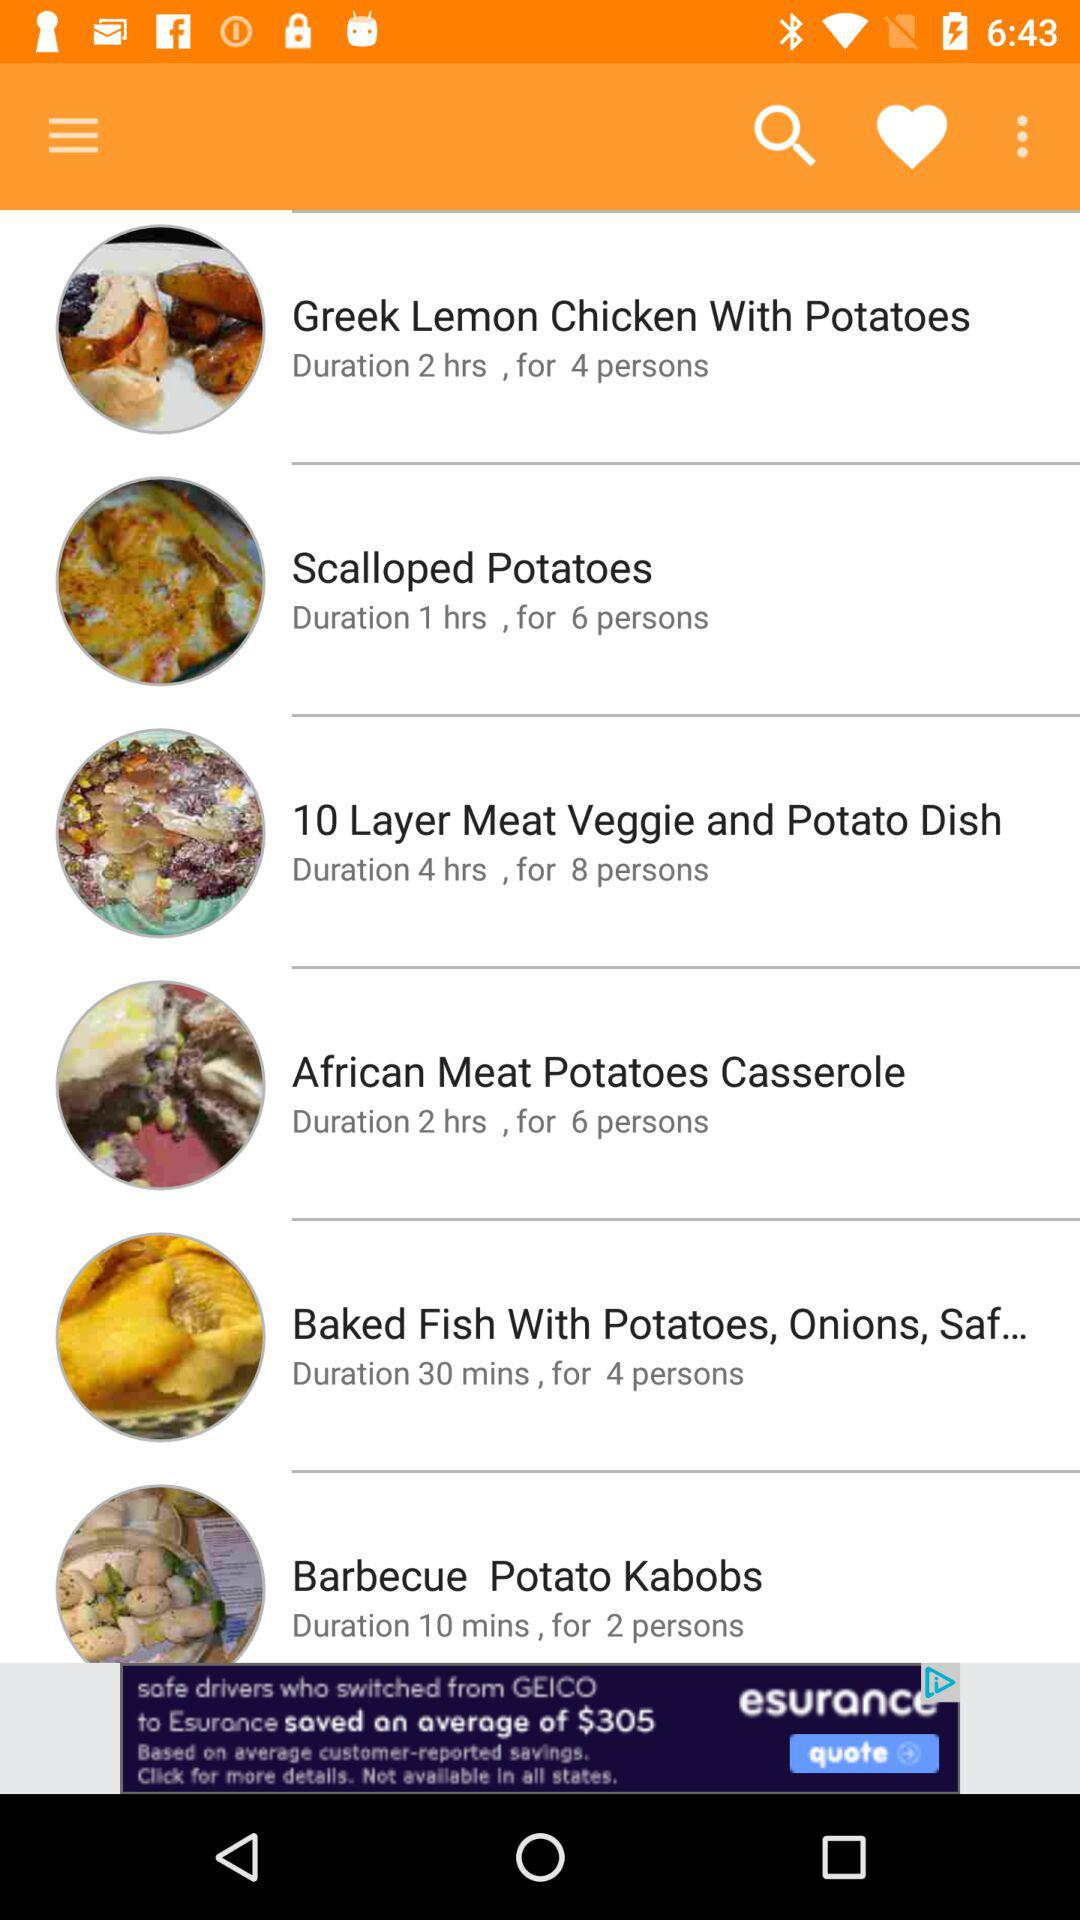How many dishes are for less than 2 hours?
Answer the question using a single word or phrase. 3 